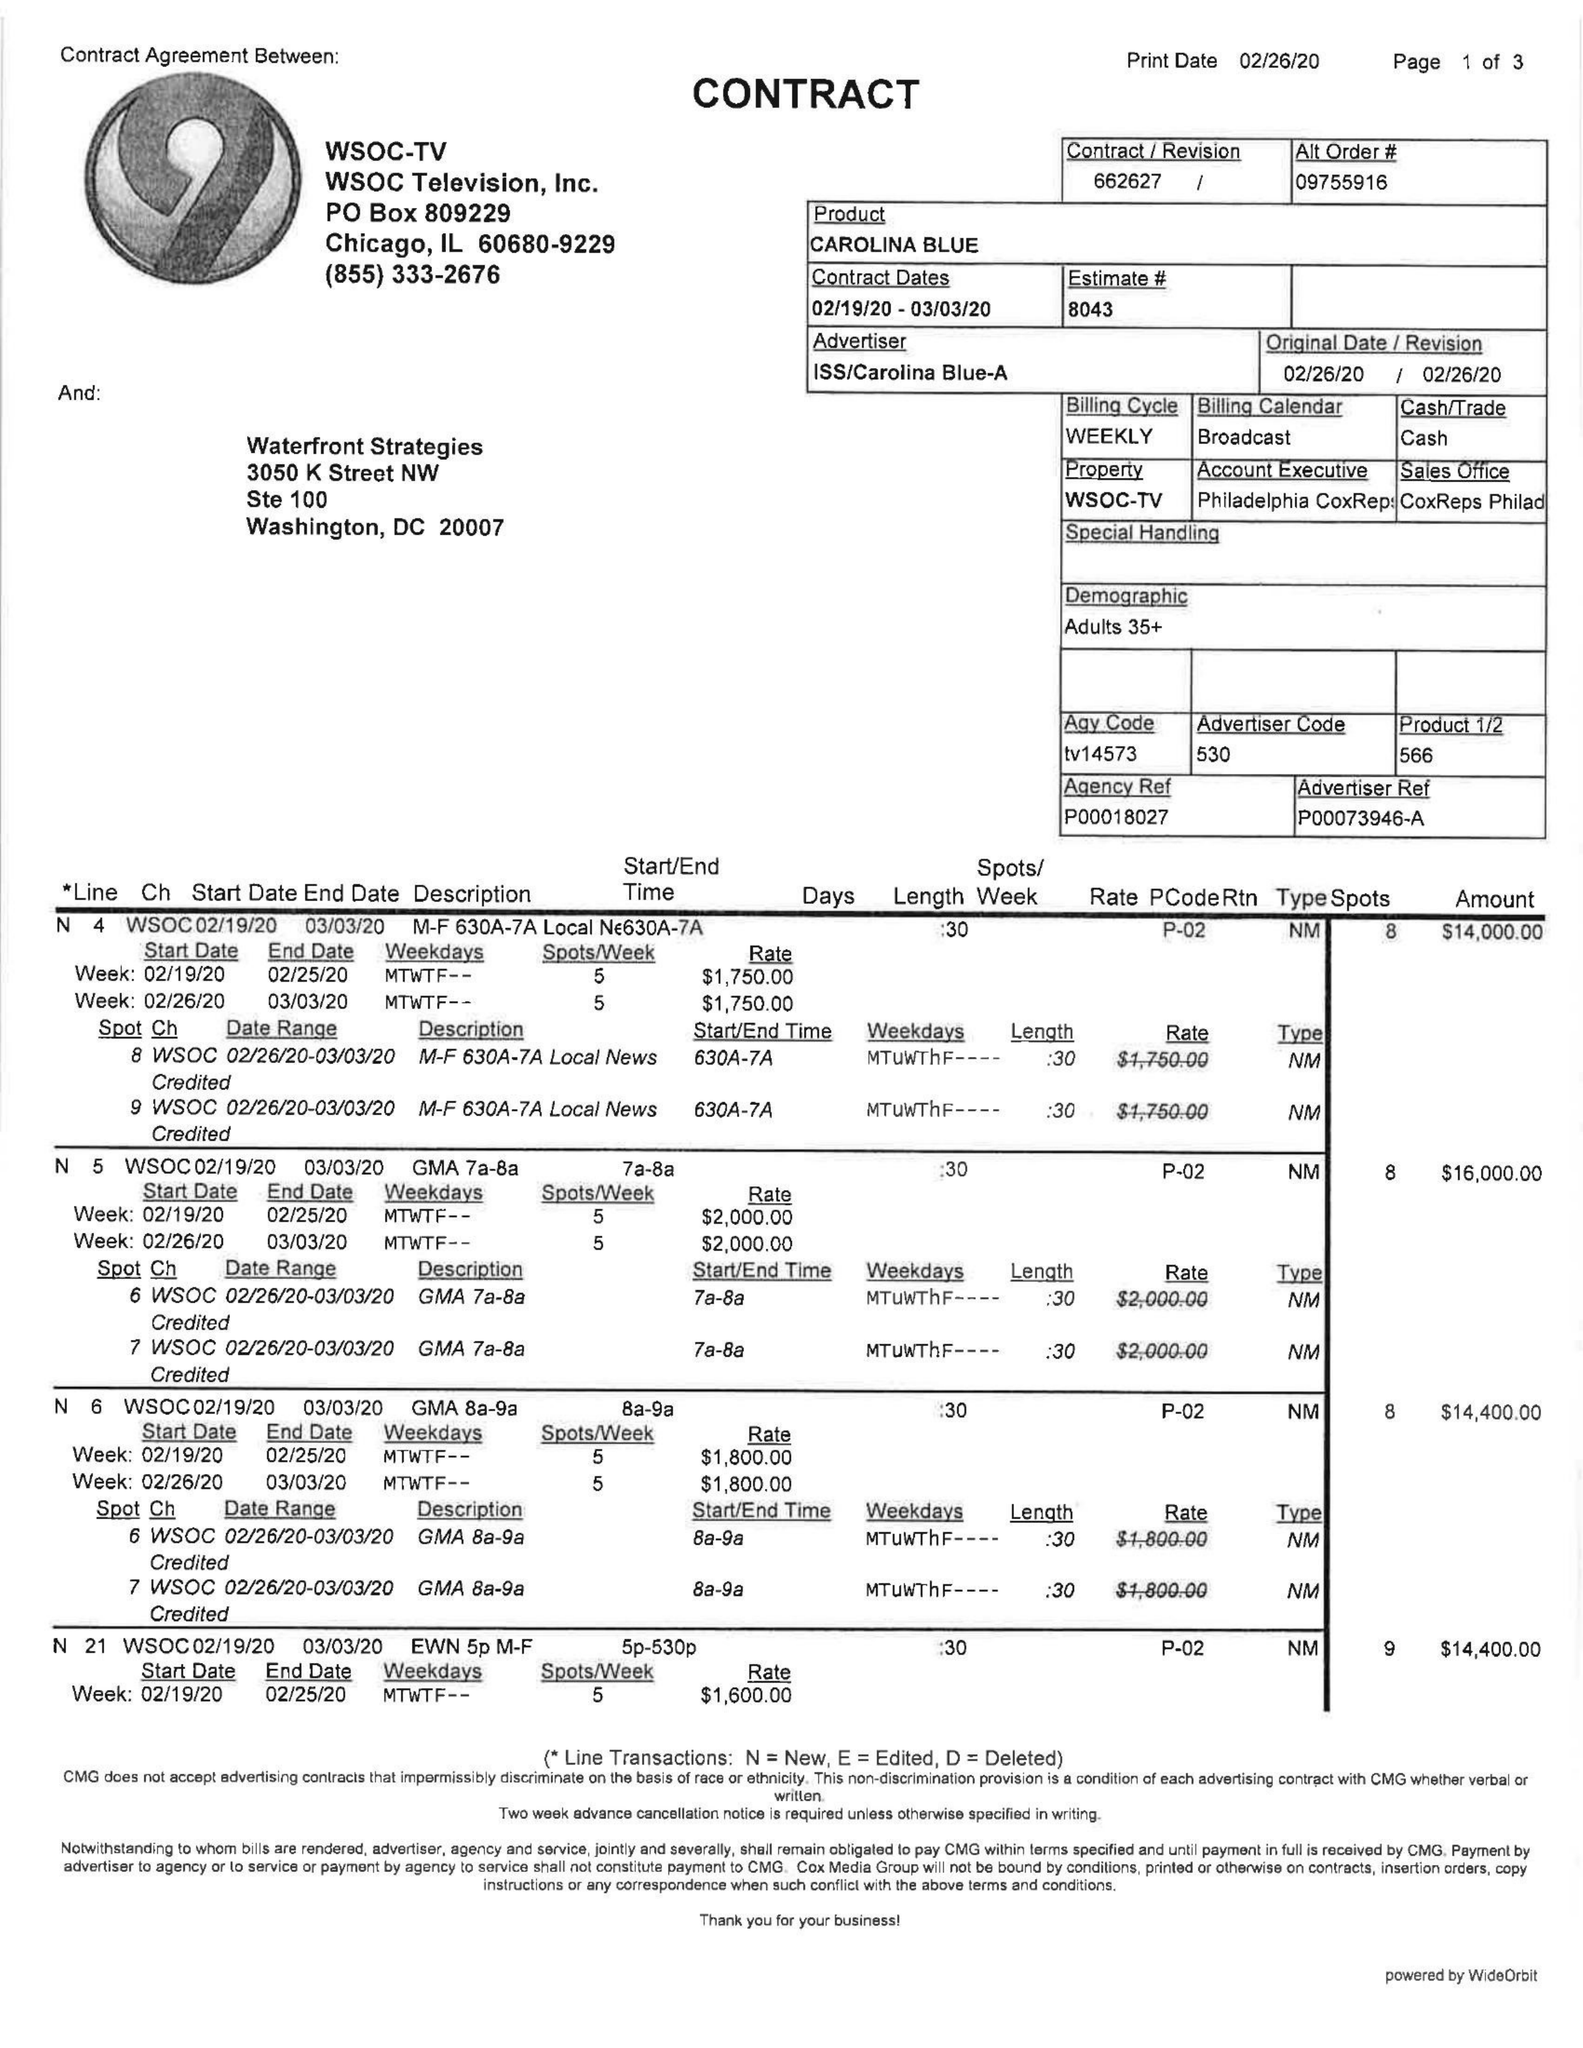What is the value for the flight_from?
Answer the question using a single word or phrase. 02/19/20 